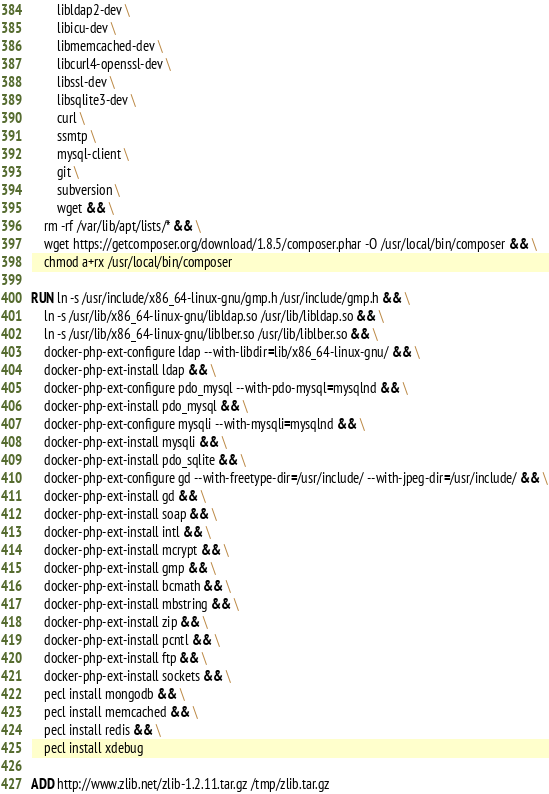Convert code to text. <code><loc_0><loc_0><loc_500><loc_500><_Dockerfile_>        libldap2-dev \
        libicu-dev \
        libmemcached-dev \
        libcurl4-openssl-dev \
        libssl-dev \
        libsqlite3-dev \
        curl \
        ssmtp \
        mysql-client \
        git \
        subversion \
        wget && \
    rm -rf /var/lib/apt/lists/* && \
    wget https://getcomposer.org/download/1.8.5/composer.phar -O /usr/local/bin/composer && \
    chmod a+rx /usr/local/bin/composer

RUN ln -s /usr/include/x86_64-linux-gnu/gmp.h /usr/include/gmp.h && \
    ln -s /usr/lib/x86_64-linux-gnu/libldap.so /usr/lib/libldap.so && \
    ln -s /usr/lib/x86_64-linux-gnu/liblber.so /usr/lib/liblber.so && \
    docker-php-ext-configure ldap --with-libdir=lib/x86_64-linux-gnu/ && \
    docker-php-ext-install ldap && \
    docker-php-ext-configure pdo_mysql --with-pdo-mysql=mysqlnd && \
    docker-php-ext-install pdo_mysql && \
    docker-php-ext-configure mysqli --with-mysqli=mysqlnd && \
    docker-php-ext-install mysqli && \
    docker-php-ext-install pdo_sqlite && \
    docker-php-ext-configure gd --with-freetype-dir=/usr/include/ --with-jpeg-dir=/usr/include/ && \
    docker-php-ext-install gd && \
    docker-php-ext-install soap && \
    docker-php-ext-install intl && \
    docker-php-ext-install mcrypt && \
    docker-php-ext-install gmp && \
    docker-php-ext-install bcmath && \
    docker-php-ext-install mbstring && \
    docker-php-ext-install zip && \
    docker-php-ext-install pcntl && \
    docker-php-ext-install ftp && \
    docker-php-ext-install sockets && \
    pecl install mongodb && \
    pecl install memcached && \
    pecl install redis && \
    pecl install xdebug

ADD http://www.zlib.net/zlib-1.2.11.tar.gz /tmp/zlib.tar.gz</code> 